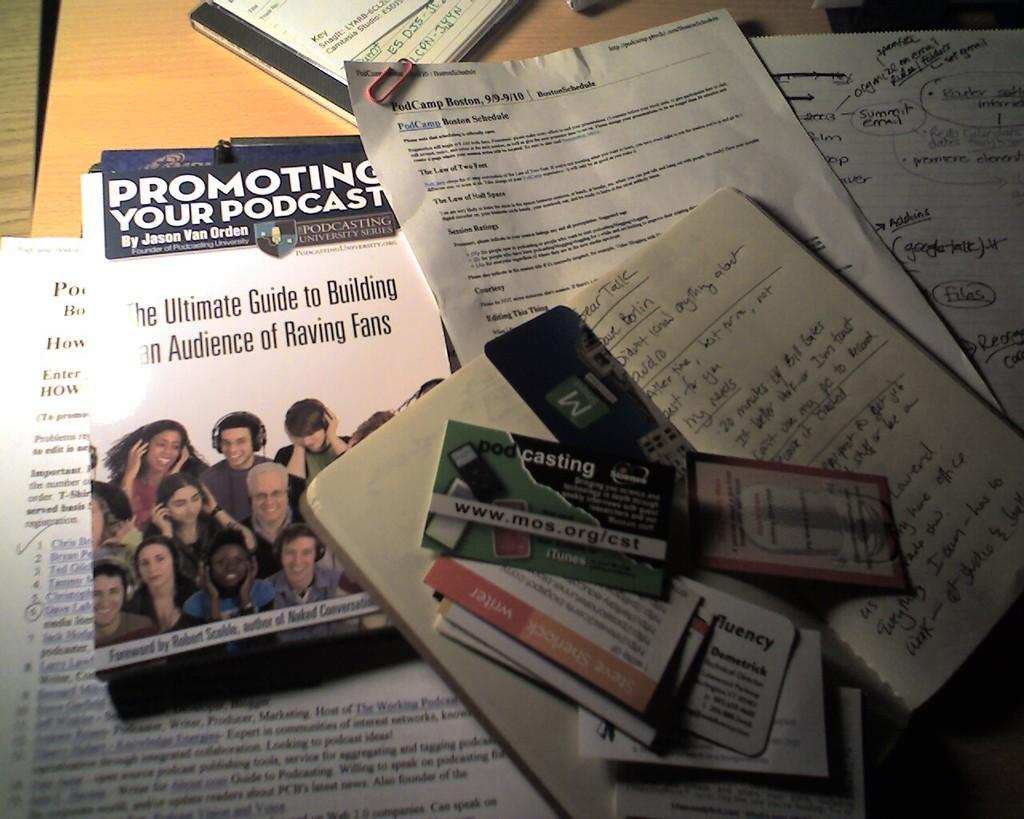<image>
Provide a brief description of the given image. a lot of papers with a pamhlet called "promoting your podcast" by jason Van orden. 